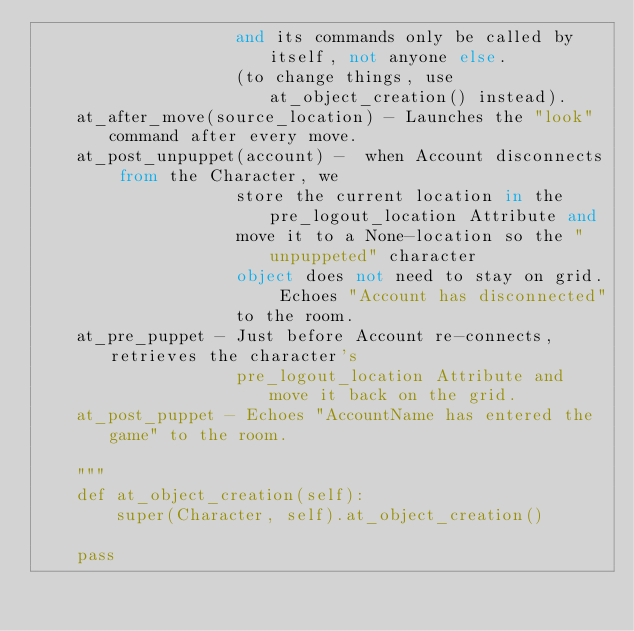<code> <loc_0><loc_0><loc_500><loc_500><_Python_>                    and its commands only be called by itself, not anyone else.
                    (to change things, use at_object_creation() instead).
    at_after_move(source_location) - Launches the "look" command after every move.
    at_post_unpuppet(account) -  when Account disconnects from the Character, we
                    store the current location in the pre_logout_location Attribute and
                    move it to a None-location so the "unpuppeted" character
                    object does not need to stay on grid. Echoes "Account has disconnected"
                    to the room.
    at_pre_puppet - Just before Account re-connects, retrieves the character's
                    pre_logout_location Attribute and move it back on the grid.
    at_post_puppet - Echoes "AccountName has entered the game" to the room.

    """
    def at_object_creation(self):
        super(Character, self).at_object_creation()

    pass
</code> 